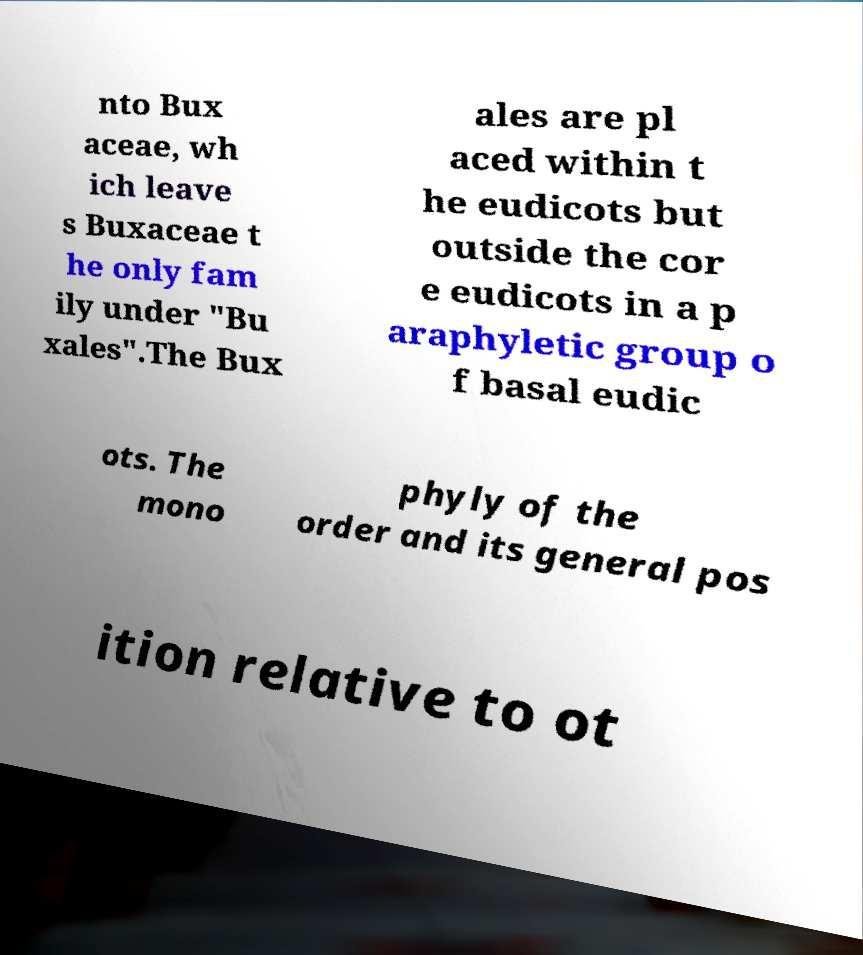Please identify and transcribe the text found in this image. nto Bux aceae, wh ich leave s Buxaceae t he only fam ily under "Bu xales".The Bux ales are pl aced within t he eudicots but outside the cor e eudicots in a p araphyletic group o f basal eudic ots. The mono phyly of the order and its general pos ition relative to ot 